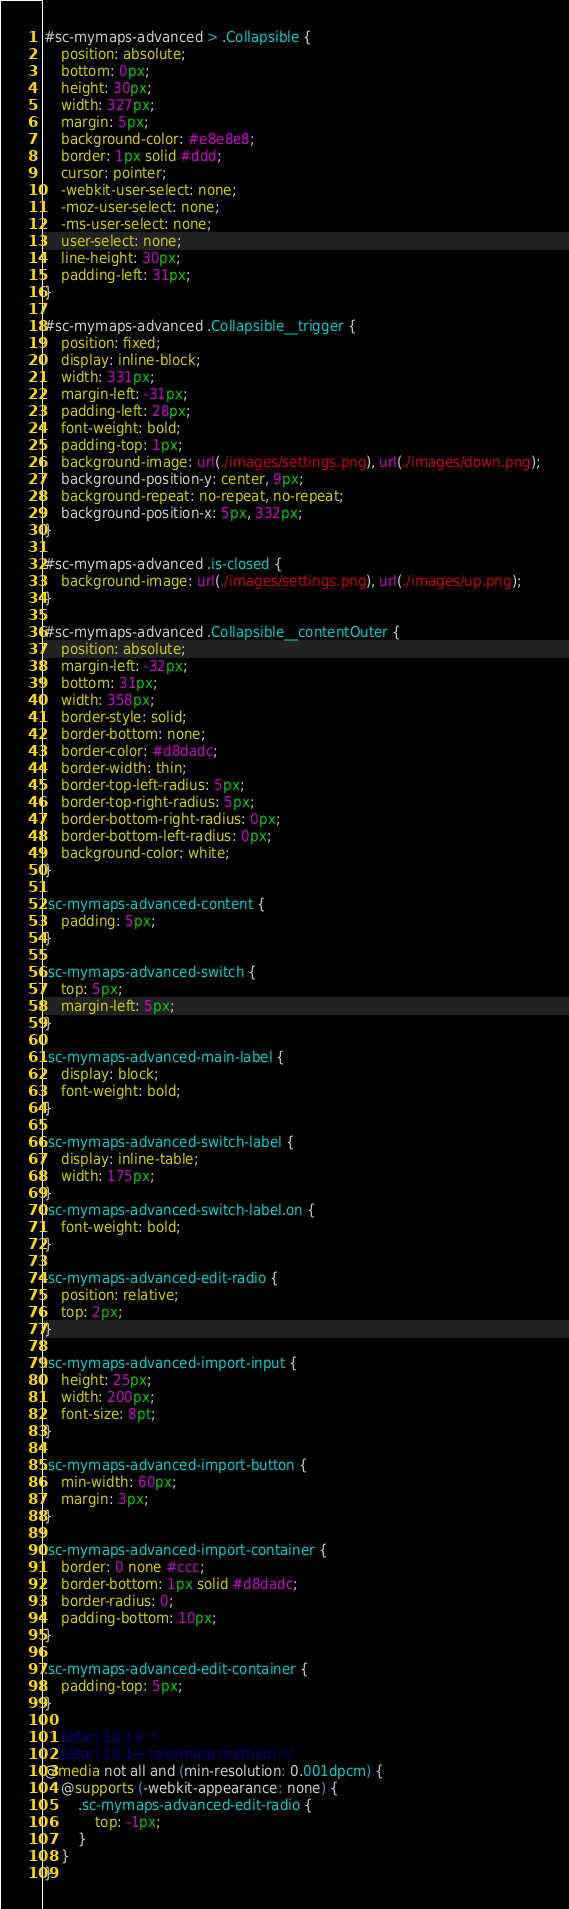Convert code to text. <code><loc_0><loc_0><loc_500><loc_500><_CSS_>#sc-mymaps-advanced > .Collapsible {
	position: absolute;
	bottom: 0px;
	height: 30px;
	width: 327px;
	margin: 5px;
	background-color: #e8e8e8;
	border: 1px solid #ddd;
	cursor: pointer;
	-webkit-user-select: none;
	-moz-user-select: none;
	-ms-user-select: none;
	user-select: none;
	line-height: 30px;
	padding-left: 31px;
}

#sc-mymaps-advanced .Collapsible__trigger {
	position: fixed;
	display: inline-block;
	width: 331px;
	margin-left: -31px;
	padding-left: 28px;
	font-weight: bold;
	padding-top: 1px;
	background-image: url(./images/settings.png), url(./images/down.png);
	background-position-y: center, 9px;
	background-repeat: no-repeat, no-repeat;
	background-position-x: 5px, 332px;
}

#sc-mymaps-advanced .is-closed {
	background-image: url(./images/settings.png), url(./images/up.png);
}

#sc-mymaps-advanced .Collapsible__contentOuter {
	position: absolute;
	margin-left: -32px;
	bottom: 31px;
	width: 358px;
	border-style: solid;
	border-bottom: none;
	border-color: #d8dadc;
	border-width: thin;
	border-top-left-radius: 5px;
	border-top-right-radius: 5px;
	border-bottom-right-radius: 0px;
	border-bottom-left-radius: 0px;
	background-color: white;
}

.sc-mymaps-advanced-content {
	padding: 5px;
}

.sc-mymaps-advanced-switch {
	top: 5px;
	margin-left: 5px;
}

.sc-mymaps-advanced-main-label {
	display: block;
	font-weight: bold;
}

.sc-mymaps-advanced-switch-label {
	display: inline-table;
	width: 175px;
}
.sc-mymaps-advanced-switch-label.on {
	font-weight: bold;
}

.sc-mymaps-advanced-edit-radio {
	position: relative;
	top: 2px;
}

.sc-mymaps-advanced-import-input {
	height: 25px;
	width: 200px;
	font-size: 8pt;
}

.sc-mymaps-advanced-import-button {
	min-width: 60px;
	margin: 3px;
}

.sc-mymaps-advanced-import-container {
	border: 0 none #ccc;
	border-bottom: 1px solid #d8dadc;
	border-radius: 0;
	padding-bottom: 10px;
}

.sc-mymaps-advanced-edit-container {
	padding-top: 5px;
}

/* Safari 10.1+ */
/* Safari 10.1+ (alternate method) */
@media not all and (min-resolution: 0.001dpcm) {
	@supports (-webkit-appearance: none) {
		.sc-mymaps-advanced-edit-radio {
			top: -1px;
		}
	}
}
</code> 